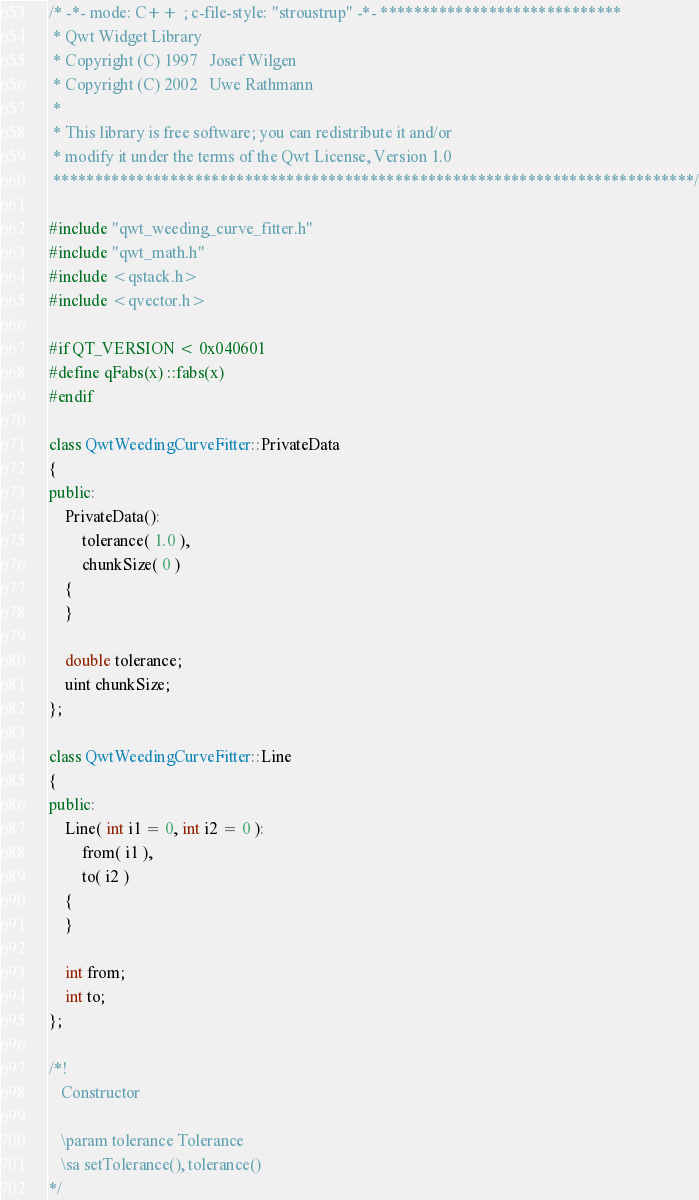Convert code to text. <code><loc_0><loc_0><loc_500><loc_500><_C++_>/* -*- mode: C++ ; c-file-style: "stroustrup" -*- *****************************
 * Qwt Widget Library
 * Copyright (C) 1997   Josef Wilgen
 * Copyright (C) 2002   Uwe Rathmann
 *
 * This library is free software; you can redistribute it and/or
 * modify it under the terms of the Qwt License, Version 1.0
 *****************************************************************************/

#include "qwt_weeding_curve_fitter.h"
#include "qwt_math.h"
#include <qstack.h>
#include <qvector.h>

#if QT_VERSION < 0x040601
#define qFabs(x) ::fabs(x)
#endif

class QwtWeedingCurveFitter::PrivateData
{
public:
    PrivateData():
        tolerance( 1.0 ),
        chunkSize( 0 )
    {
    }

    double tolerance;
    uint chunkSize;
};

class QwtWeedingCurveFitter::Line
{
public:
    Line( int i1 = 0, int i2 = 0 ):
        from( i1 ),
        to( i2 )
    {
    }

    int from;
    int to;
};

/*!
   Constructor

   \param tolerance Tolerance
   \sa setTolerance(), tolerance()
*/</code> 